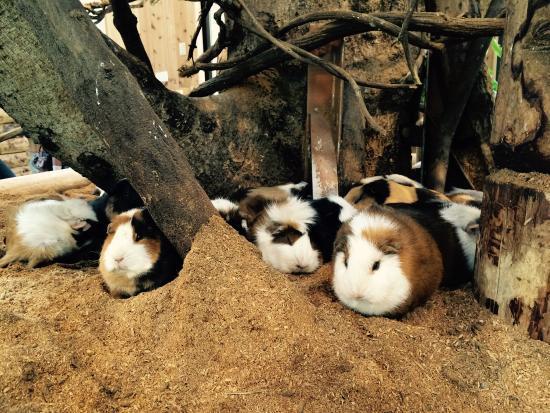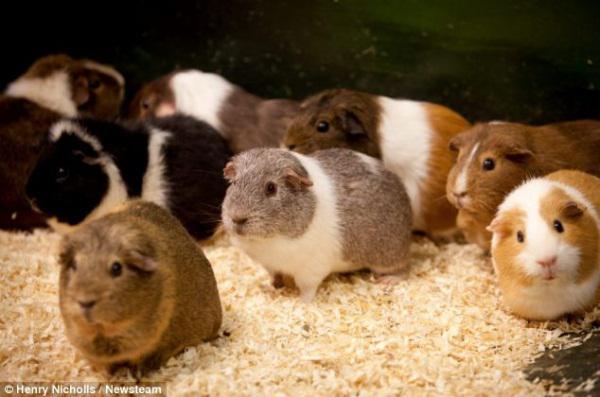The first image is the image on the left, the second image is the image on the right. For the images shown, is this caption "There is a bowl in the image on the right." true? Answer yes or no. No. 